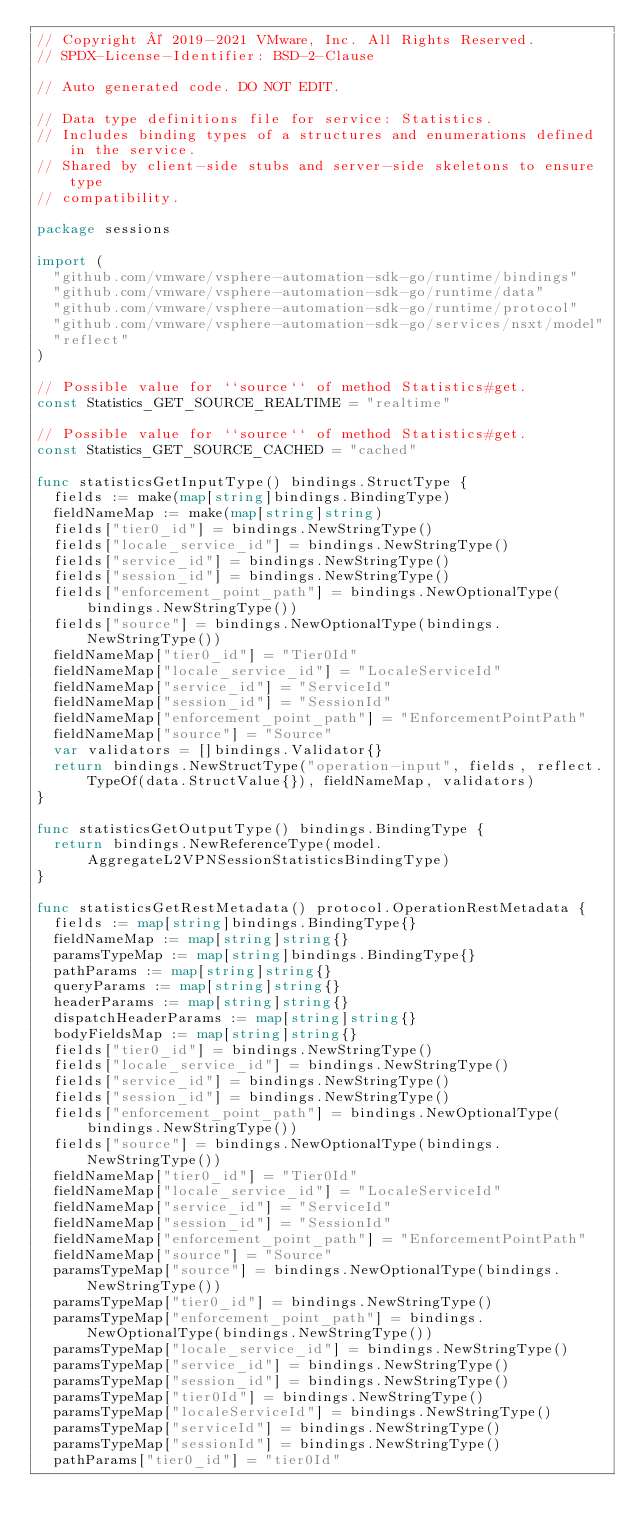Convert code to text. <code><loc_0><loc_0><loc_500><loc_500><_Go_>// Copyright © 2019-2021 VMware, Inc. All Rights Reserved.
// SPDX-License-Identifier: BSD-2-Clause

// Auto generated code. DO NOT EDIT.

// Data type definitions file for service: Statistics.
// Includes binding types of a structures and enumerations defined in the service.
// Shared by client-side stubs and server-side skeletons to ensure type
// compatibility.

package sessions

import (
	"github.com/vmware/vsphere-automation-sdk-go/runtime/bindings"
	"github.com/vmware/vsphere-automation-sdk-go/runtime/data"
	"github.com/vmware/vsphere-automation-sdk-go/runtime/protocol"
	"github.com/vmware/vsphere-automation-sdk-go/services/nsxt/model"
	"reflect"
)

// Possible value for ``source`` of method Statistics#get.
const Statistics_GET_SOURCE_REALTIME = "realtime"

// Possible value for ``source`` of method Statistics#get.
const Statistics_GET_SOURCE_CACHED = "cached"

func statisticsGetInputType() bindings.StructType {
	fields := make(map[string]bindings.BindingType)
	fieldNameMap := make(map[string]string)
	fields["tier0_id"] = bindings.NewStringType()
	fields["locale_service_id"] = bindings.NewStringType()
	fields["service_id"] = bindings.NewStringType()
	fields["session_id"] = bindings.NewStringType()
	fields["enforcement_point_path"] = bindings.NewOptionalType(bindings.NewStringType())
	fields["source"] = bindings.NewOptionalType(bindings.NewStringType())
	fieldNameMap["tier0_id"] = "Tier0Id"
	fieldNameMap["locale_service_id"] = "LocaleServiceId"
	fieldNameMap["service_id"] = "ServiceId"
	fieldNameMap["session_id"] = "SessionId"
	fieldNameMap["enforcement_point_path"] = "EnforcementPointPath"
	fieldNameMap["source"] = "Source"
	var validators = []bindings.Validator{}
	return bindings.NewStructType("operation-input", fields, reflect.TypeOf(data.StructValue{}), fieldNameMap, validators)
}

func statisticsGetOutputType() bindings.BindingType {
	return bindings.NewReferenceType(model.AggregateL2VPNSessionStatisticsBindingType)
}

func statisticsGetRestMetadata() protocol.OperationRestMetadata {
	fields := map[string]bindings.BindingType{}
	fieldNameMap := map[string]string{}
	paramsTypeMap := map[string]bindings.BindingType{}
	pathParams := map[string]string{}
	queryParams := map[string]string{}
	headerParams := map[string]string{}
	dispatchHeaderParams := map[string]string{}
	bodyFieldsMap := map[string]string{}
	fields["tier0_id"] = bindings.NewStringType()
	fields["locale_service_id"] = bindings.NewStringType()
	fields["service_id"] = bindings.NewStringType()
	fields["session_id"] = bindings.NewStringType()
	fields["enforcement_point_path"] = bindings.NewOptionalType(bindings.NewStringType())
	fields["source"] = bindings.NewOptionalType(bindings.NewStringType())
	fieldNameMap["tier0_id"] = "Tier0Id"
	fieldNameMap["locale_service_id"] = "LocaleServiceId"
	fieldNameMap["service_id"] = "ServiceId"
	fieldNameMap["session_id"] = "SessionId"
	fieldNameMap["enforcement_point_path"] = "EnforcementPointPath"
	fieldNameMap["source"] = "Source"
	paramsTypeMap["source"] = bindings.NewOptionalType(bindings.NewStringType())
	paramsTypeMap["tier0_id"] = bindings.NewStringType()
	paramsTypeMap["enforcement_point_path"] = bindings.NewOptionalType(bindings.NewStringType())
	paramsTypeMap["locale_service_id"] = bindings.NewStringType()
	paramsTypeMap["service_id"] = bindings.NewStringType()
	paramsTypeMap["session_id"] = bindings.NewStringType()
	paramsTypeMap["tier0Id"] = bindings.NewStringType()
	paramsTypeMap["localeServiceId"] = bindings.NewStringType()
	paramsTypeMap["serviceId"] = bindings.NewStringType()
	paramsTypeMap["sessionId"] = bindings.NewStringType()
	pathParams["tier0_id"] = "tier0Id"</code> 